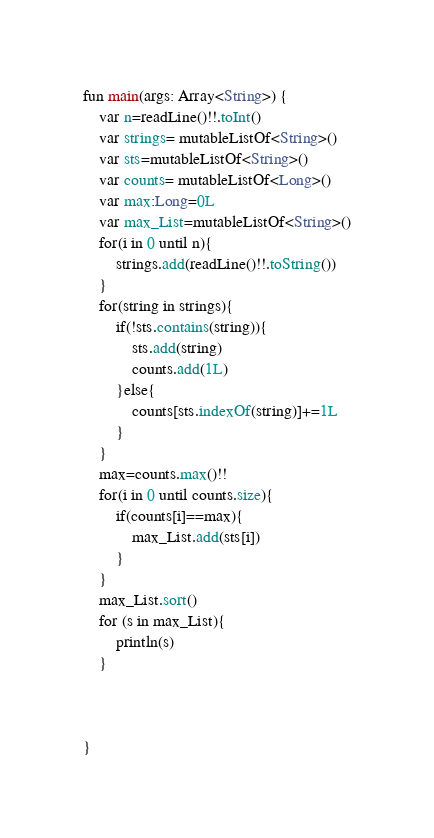Convert code to text. <code><loc_0><loc_0><loc_500><loc_500><_Kotlin_>fun main(args: Array<String>) {
    var n=readLine()!!.toInt()
    var strings= mutableListOf<String>()
    var sts=mutableListOf<String>()
    var counts= mutableListOf<Long>()
    var max:Long=0L
    var max_List=mutableListOf<String>()
    for(i in 0 until n){
        strings.add(readLine()!!.toString())
    }
    for(string in strings){
        if(!sts.contains(string)){
            sts.add(string)
            counts.add(1L)
        }else{
            counts[sts.indexOf(string)]+=1L
        }
    }
    max=counts.max()!!
    for(i in 0 until counts.size){
        if(counts[i]==max){
            max_List.add(sts[i])
        }
    }
    max_List.sort()
    for (s in max_List){
        println(s)
    }



}</code> 